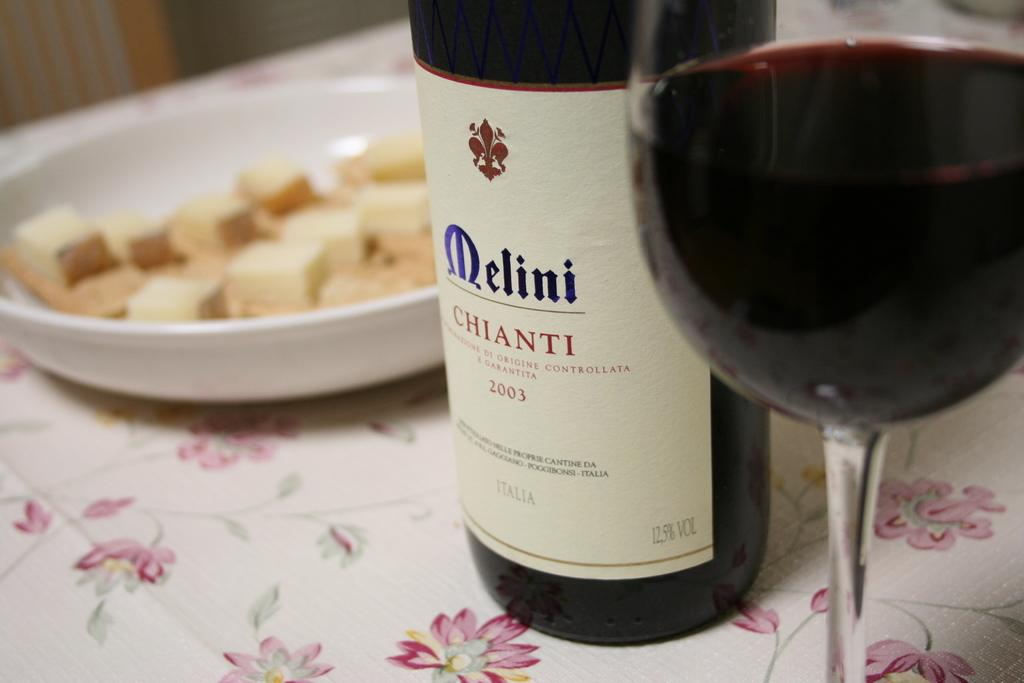What is contained in the bottle in the image? The facts provided do not specify what is in the bottle. What is in the glass in the image? There is wine in a glass in the image. What is in the bowl in the image? There is cheese in the bowl in the image. What is covering the table in the image? There is a white cloth on the table in the image. How many health benefits can be observed from the cracker in the image? There is no cracker present in the image, so it is not possible to determine any health benefits. 